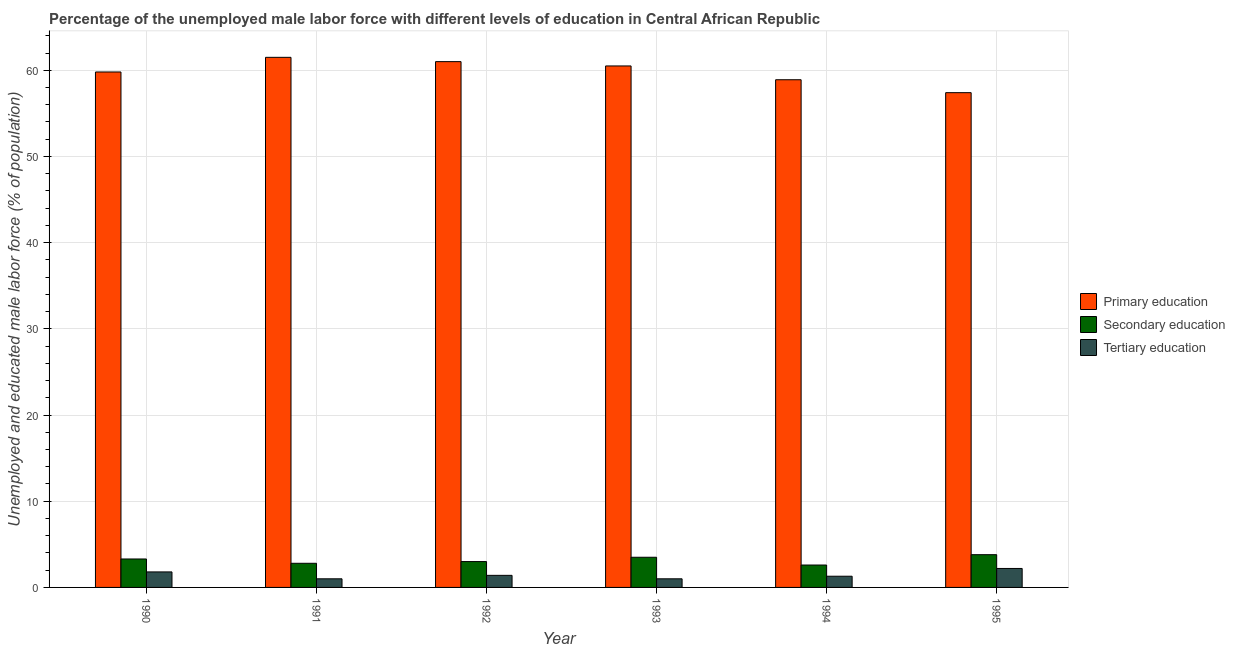How many groups of bars are there?
Provide a short and direct response. 6. How many bars are there on the 4th tick from the right?
Your answer should be very brief. 3. In how many cases, is the number of bars for a given year not equal to the number of legend labels?
Provide a short and direct response. 0. What is the percentage of male labor force who received primary education in 1993?
Make the answer very short. 60.5. Across all years, what is the maximum percentage of male labor force who received secondary education?
Your response must be concise. 3.8. Across all years, what is the minimum percentage of male labor force who received secondary education?
Offer a terse response. 2.6. In which year was the percentage of male labor force who received tertiary education maximum?
Keep it short and to the point. 1995. What is the total percentage of male labor force who received tertiary education in the graph?
Provide a short and direct response. 8.7. What is the difference between the percentage of male labor force who received primary education in 1991 and that in 1994?
Your response must be concise. 2.6. What is the difference between the percentage of male labor force who received primary education in 1991 and the percentage of male labor force who received secondary education in 1992?
Offer a terse response. 0.5. What is the average percentage of male labor force who received primary education per year?
Your response must be concise. 59.85. In the year 1991, what is the difference between the percentage of male labor force who received tertiary education and percentage of male labor force who received primary education?
Keep it short and to the point. 0. What is the ratio of the percentage of male labor force who received primary education in 1992 to that in 1993?
Make the answer very short. 1.01. Is the difference between the percentage of male labor force who received primary education in 1991 and 1993 greater than the difference between the percentage of male labor force who received secondary education in 1991 and 1993?
Make the answer very short. No. What is the difference between the highest and the second highest percentage of male labor force who received primary education?
Your response must be concise. 0.5. What is the difference between the highest and the lowest percentage of male labor force who received primary education?
Provide a succinct answer. 4.1. What does the 1st bar from the right in 1994 represents?
Provide a succinct answer. Tertiary education. Is it the case that in every year, the sum of the percentage of male labor force who received primary education and percentage of male labor force who received secondary education is greater than the percentage of male labor force who received tertiary education?
Your answer should be very brief. Yes. How many bars are there?
Give a very brief answer. 18. What is the difference between two consecutive major ticks on the Y-axis?
Make the answer very short. 10. Does the graph contain any zero values?
Your answer should be compact. No. How many legend labels are there?
Your answer should be compact. 3. How are the legend labels stacked?
Provide a short and direct response. Vertical. What is the title of the graph?
Your answer should be very brief. Percentage of the unemployed male labor force with different levels of education in Central African Republic. Does "Social insurance" appear as one of the legend labels in the graph?
Offer a very short reply. No. What is the label or title of the X-axis?
Give a very brief answer. Year. What is the label or title of the Y-axis?
Provide a succinct answer. Unemployed and educated male labor force (% of population). What is the Unemployed and educated male labor force (% of population) in Primary education in 1990?
Provide a succinct answer. 59.8. What is the Unemployed and educated male labor force (% of population) in Secondary education in 1990?
Your response must be concise. 3.3. What is the Unemployed and educated male labor force (% of population) in Tertiary education in 1990?
Keep it short and to the point. 1.8. What is the Unemployed and educated male labor force (% of population) of Primary education in 1991?
Ensure brevity in your answer.  61.5. What is the Unemployed and educated male labor force (% of population) of Secondary education in 1991?
Ensure brevity in your answer.  2.8. What is the Unemployed and educated male labor force (% of population) in Tertiary education in 1992?
Your response must be concise. 1.4. What is the Unemployed and educated male labor force (% of population) in Primary education in 1993?
Provide a succinct answer. 60.5. What is the Unemployed and educated male labor force (% of population) of Tertiary education in 1993?
Your response must be concise. 1. What is the Unemployed and educated male labor force (% of population) in Primary education in 1994?
Ensure brevity in your answer.  58.9. What is the Unemployed and educated male labor force (% of population) in Secondary education in 1994?
Your response must be concise. 2.6. What is the Unemployed and educated male labor force (% of population) in Tertiary education in 1994?
Give a very brief answer. 1.3. What is the Unemployed and educated male labor force (% of population) in Primary education in 1995?
Give a very brief answer. 57.4. What is the Unemployed and educated male labor force (% of population) in Secondary education in 1995?
Offer a terse response. 3.8. What is the Unemployed and educated male labor force (% of population) in Tertiary education in 1995?
Offer a terse response. 2.2. Across all years, what is the maximum Unemployed and educated male labor force (% of population) of Primary education?
Make the answer very short. 61.5. Across all years, what is the maximum Unemployed and educated male labor force (% of population) of Secondary education?
Offer a terse response. 3.8. Across all years, what is the maximum Unemployed and educated male labor force (% of population) in Tertiary education?
Provide a short and direct response. 2.2. Across all years, what is the minimum Unemployed and educated male labor force (% of population) of Primary education?
Ensure brevity in your answer.  57.4. Across all years, what is the minimum Unemployed and educated male labor force (% of population) of Secondary education?
Your answer should be compact. 2.6. Across all years, what is the minimum Unemployed and educated male labor force (% of population) in Tertiary education?
Give a very brief answer. 1. What is the total Unemployed and educated male labor force (% of population) in Primary education in the graph?
Ensure brevity in your answer.  359.1. What is the total Unemployed and educated male labor force (% of population) of Secondary education in the graph?
Make the answer very short. 19. What is the difference between the Unemployed and educated male labor force (% of population) in Primary education in 1990 and that in 1991?
Give a very brief answer. -1.7. What is the difference between the Unemployed and educated male labor force (% of population) in Secondary education in 1990 and that in 1991?
Your answer should be very brief. 0.5. What is the difference between the Unemployed and educated male labor force (% of population) in Primary education in 1990 and that in 1992?
Keep it short and to the point. -1.2. What is the difference between the Unemployed and educated male labor force (% of population) in Secondary education in 1990 and that in 1992?
Make the answer very short. 0.3. What is the difference between the Unemployed and educated male labor force (% of population) of Tertiary education in 1990 and that in 1992?
Give a very brief answer. 0.4. What is the difference between the Unemployed and educated male labor force (% of population) in Primary education in 1990 and that in 1994?
Your answer should be compact. 0.9. What is the difference between the Unemployed and educated male labor force (% of population) of Tertiary education in 1990 and that in 1994?
Give a very brief answer. 0.5. What is the difference between the Unemployed and educated male labor force (% of population) in Secondary education in 1991 and that in 1993?
Your answer should be compact. -0.7. What is the difference between the Unemployed and educated male labor force (% of population) of Primary education in 1991 and that in 1994?
Provide a short and direct response. 2.6. What is the difference between the Unemployed and educated male labor force (% of population) of Tertiary education in 1991 and that in 1994?
Provide a succinct answer. -0.3. What is the difference between the Unemployed and educated male labor force (% of population) in Primary education in 1991 and that in 1995?
Your response must be concise. 4.1. What is the difference between the Unemployed and educated male labor force (% of population) in Tertiary education in 1991 and that in 1995?
Provide a succinct answer. -1.2. What is the difference between the Unemployed and educated male labor force (% of population) of Primary education in 1992 and that in 1993?
Provide a succinct answer. 0.5. What is the difference between the Unemployed and educated male labor force (% of population) in Secondary education in 1992 and that in 1994?
Ensure brevity in your answer.  0.4. What is the difference between the Unemployed and educated male labor force (% of population) of Secondary education in 1992 and that in 1995?
Offer a very short reply. -0.8. What is the difference between the Unemployed and educated male labor force (% of population) in Tertiary education in 1992 and that in 1995?
Your answer should be compact. -0.8. What is the difference between the Unemployed and educated male labor force (% of population) of Primary education in 1993 and that in 1994?
Your answer should be very brief. 1.6. What is the difference between the Unemployed and educated male labor force (% of population) of Secondary education in 1993 and that in 1994?
Offer a terse response. 0.9. What is the difference between the Unemployed and educated male labor force (% of population) in Tertiary education in 1993 and that in 1994?
Give a very brief answer. -0.3. What is the difference between the Unemployed and educated male labor force (% of population) in Primary education in 1993 and that in 1995?
Provide a succinct answer. 3.1. What is the difference between the Unemployed and educated male labor force (% of population) of Secondary education in 1993 and that in 1995?
Your answer should be very brief. -0.3. What is the difference between the Unemployed and educated male labor force (% of population) of Tertiary education in 1993 and that in 1995?
Offer a very short reply. -1.2. What is the difference between the Unemployed and educated male labor force (% of population) of Tertiary education in 1994 and that in 1995?
Your answer should be very brief. -0.9. What is the difference between the Unemployed and educated male labor force (% of population) of Primary education in 1990 and the Unemployed and educated male labor force (% of population) of Tertiary education in 1991?
Ensure brevity in your answer.  58.8. What is the difference between the Unemployed and educated male labor force (% of population) of Secondary education in 1990 and the Unemployed and educated male labor force (% of population) of Tertiary education in 1991?
Ensure brevity in your answer.  2.3. What is the difference between the Unemployed and educated male labor force (% of population) in Primary education in 1990 and the Unemployed and educated male labor force (% of population) in Secondary education in 1992?
Provide a succinct answer. 56.8. What is the difference between the Unemployed and educated male labor force (% of population) of Primary education in 1990 and the Unemployed and educated male labor force (% of population) of Tertiary education in 1992?
Keep it short and to the point. 58.4. What is the difference between the Unemployed and educated male labor force (% of population) of Primary education in 1990 and the Unemployed and educated male labor force (% of population) of Secondary education in 1993?
Provide a succinct answer. 56.3. What is the difference between the Unemployed and educated male labor force (% of population) in Primary education in 1990 and the Unemployed and educated male labor force (% of population) in Tertiary education in 1993?
Your response must be concise. 58.8. What is the difference between the Unemployed and educated male labor force (% of population) in Secondary education in 1990 and the Unemployed and educated male labor force (% of population) in Tertiary education in 1993?
Keep it short and to the point. 2.3. What is the difference between the Unemployed and educated male labor force (% of population) in Primary education in 1990 and the Unemployed and educated male labor force (% of population) in Secondary education in 1994?
Provide a short and direct response. 57.2. What is the difference between the Unemployed and educated male labor force (% of population) in Primary education in 1990 and the Unemployed and educated male labor force (% of population) in Tertiary education in 1994?
Your response must be concise. 58.5. What is the difference between the Unemployed and educated male labor force (% of population) of Secondary education in 1990 and the Unemployed and educated male labor force (% of population) of Tertiary education in 1994?
Your response must be concise. 2. What is the difference between the Unemployed and educated male labor force (% of population) of Primary education in 1990 and the Unemployed and educated male labor force (% of population) of Tertiary education in 1995?
Keep it short and to the point. 57.6. What is the difference between the Unemployed and educated male labor force (% of population) in Primary education in 1991 and the Unemployed and educated male labor force (% of population) in Secondary education in 1992?
Your answer should be very brief. 58.5. What is the difference between the Unemployed and educated male labor force (% of population) in Primary education in 1991 and the Unemployed and educated male labor force (% of population) in Tertiary education in 1992?
Offer a terse response. 60.1. What is the difference between the Unemployed and educated male labor force (% of population) in Secondary education in 1991 and the Unemployed and educated male labor force (% of population) in Tertiary education in 1992?
Keep it short and to the point. 1.4. What is the difference between the Unemployed and educated male labor force (% of population) in Primary education in 1991 and the Unemployed and educated male labor force (% of population) in Secondary education in 1993?
Provide a short and direct response. 58. What is the difference between the Unemployed and educated male labor force (% of population) in Primary education in 1991 and the Unemployed and educated male labor force (% of population) in Tertiary education in 1993?
Offer a terse response. 60.5. What is the difference between the Unemployed and educated male labor force (% of population) in Primary education in 1991 and the Unemployed and educated male labor force (% of population) in Secondary education in 1994?
Provide a succinct answer. 58.9. What is the difference between the Unemployed and educated male labor force (% of population) in Primary education in 1991 and the Unemployed and educated male labor force (% of population) in Tertiary education in 1994?
Keep it short and to the point. 60.2. What is the difference between the Unemployed and educated male labor force (% of population) in Primary education in 1991 and the Unemployed and educated male labor force (% of population) in Secondary education in 1995?
Your answer should be compact. 57.7. What is the difference between the Unemployed and educated male labor force (% of population) in Primary education in 1991 and the Unemployed and educated male labor force (% of population) in Tertiary education in 1995?
Provide a short and direct response. 59.3. What is the difference between the Unemployed and educated male labor force (% of population) in Primary education in 1992 and the Unemployed and educated male labor force (% of population) in Secondary education in 1993?
Offer a very short reply. 57.5. What is the difference between the Unemployed and educated male labor force (% of population) in Secondary education in 1992 and the Unemployed and educated male labor force (% of population) in Tertiary education in 1993?
Ensure brevity in your answer.  2. What is the difference between the Unemployed and educated male labor force (% of population) of Primary education in 1992 and the Unemployed and educated male labor force (% of population) of Secondary education in 1994?
Give a very brief answer. 58.4. What is the difference between the Unemployed and educated male labor force (% of population) in Primary education in 1992 and the Unemployed and educated male labor force (% of population) in Tertiary education in 1994?
Offer a terse response. 59.7. What is the difference between the Unemployed and educated male labor force (% of population) in Primary education in 1992 and the Unemployed and educated male labor force (% of population) in Secondary education in 1995?
Keep it short and to the point. 57.2. What is the difference between the Unemployed and educated male labor force (% of population) in Primary education in 1992 and the Unemployed and educated male labor force (% of population) in Tertiary education in 1995?
Keep it short and to the point. 58.8. What is the difference between the Unemployed and educated male labor force (% of population) in Secondary education in 1992 and the Unemployed and educated male labor force (% of population) in Tertiary education in 1995?
Offer a very short reply. 0.8. What is the difference between the Unemployed and educated male labor force (% of population) in Primary education in 1993 and the Unemployed and educated male labor force (% of population) in Secondary education in 1994?
Ensure brevity in your answer.  57.9. What is the difference between the Unemployed and educated male labor force (% of population) of Primary education in 1993 and the Unemployed and educated male labor force (% of population) of Tertiary education in 1994?
Give a very brief answer. 59.2. What is the difference between the Unemployed and educated male labor force (% of population) of Secondary education in 1993 and the Unemployed and educated male labor force (% of population) of Tertiary education in 1994?
Your answer should be very brief. 2.2. What is the difference between the Unemployed and educated male labor force (% of population) in Primary education in 1993 and the Unemployed and educated male labor force (% of population) in Secondary education in 1995?
Offer a very short reply. 56.7. What is the difference between the Unemployed and educated male labor force (% of population) of Primary education in 1993 and the Unemployed and educated male labor force (% of population) of Tertiary education in 1995?
Keep it short and to the point. 58.3. What is the difference between the Unemployed and educated male labor force (% of population) of Secondary education in 1993 and the Unemployed and educated male labor force (% of population) of Tertiary education in 1995?
Provide a short and direct response. 1.3. What is the difference between the Unemployed and educated male labor force (% of population) of Primary education in 1994 and the Unemployed and educated male labor force (% of population) of Secondary education in 1995?
Offer a very short reply. 55.1. What is the difference between the Unemployed and educated male labor force (% of population) of Primary education in 1994 and the Unemployed and educated male labor force (% of population) of Tertiary education in 1995?
Keep it short and to the point. 56.7. What is the difference between the Unemployed and educated male labor force (% of population) of Secondary education in 1994 and the Unemployed and educated male labor force (% of population) of Tertiary education in 1995?
Your answer should be very brief. 0.4. What is the average Unemployed and educated male labor force (% of population) in Primary education per year?
Give a very brief answer. 59.85. What is the average Unemployed and educated male labor force (% of population) of Secondary education per year?
Provide a succinct answer. 3.17. What is the average Unemployed and educated male labor force (% of population) of Tertiary education per year?
Offer a very short reply. 1.45. In the year 1990, what is the difference between the Unemployed and educated male labor force (% of population) of Primary education and Unemployed and educated male labor force (% of population) of Secondary education?
Offer a very short reply. 56.5. In the year 1990, what is the difference between the Unemployed and educated male labor force (% of population) of Primary education and Unemployed and educated male labor force (% of population) of Tertiary education?
Your response must be concise. 58. In the year 1990, what is the difference between the Unemployed and educated male labor force (% of population) in Secondary education and Unemployed and educated male labor force (% of population) in Tertiary education?
Offer a very short reply. 1.5. In the year 1991, what is the difference between the Unemployed and educated male labor force (% of population) of Primary education and Unemployed and educated male labor force (% of population) of Secondary education?
Offer a terse response. 58.7. In the year 1991, what is the difference between the Unemployed and educated male labor force (% of population) of Primary education and Unemployed and educated male labor force (% of population) of Tertiary education?
Your answer should be compact. 60.5. In the year 1992, what is the difference between the Unemployed and educated male labor force (% of population) in Primary education and Unemployed and educated male labor force (% of population) in Tertiary education?
Offer a terse response. 59.6. In the year 1992, what is the difference between the Unemployed and educated male labor force (% of population) in Secondary education and Unemployed and educated male labor force (% of population) in Tertiary education?
Give a very brief answer. 1.6. In the year 1993, what is the difference between the Unemployed and educated male labor force (% of population) in Primary education and Unemployed and educated male labor force (% of population) in Tertiary education?
Provide a succinct answer. 59.5. In the year 1993, what is the difference between the Unemployed and educated male labor force (% of population) of Secondary education and Unemployed and educated male labor force (% of population) of Tertiary education?
Your answer should be compact. 2.5. In the year 1994, what is the difference between the Unemployed and educated male labor force (% of population) of Primary education and Unemployed and educated male labor force (% of population) of Secondary education?
Offer a terse response. 56.3. In the year 1994, what is the difference between the Unemployed and educated male labor force (% of population) in Primary education and Unemployed and educated male labor force (% of population) in Tertiary education?
Provide a short and direct response. 57.6. In the year 1994, what is the difference between the Unemployed and educated male labor force (% of population) of Secondary education and Unemployed and educated male labor force (% of population) of Tertiary education?
Provide a short and direct response. 1.3. In the year 1995, what is the difference between the Unemployed and educated male labor force (% of population) of Primary education and Unemployed and educated male labor force (% of population) of Secondary education?
Make the answer very short. 53.6. In the year 1995, what is the difference between the Unemployed and educated male labor force (% of population) of Primary education and Unemployed and educated male labor force (% of population) of Tertiary education?
Your answer should be compact. 55.2. What is the ratio of the Unemployed and educated male labor force (% of population) of Primary education in 1990 to that in 1991?
Give a very brief answer. 0.97. What is the ratio of the Unemployed and educated male labor force (% of population) in Secondary education in 1990 to that in 1991?
Offer a terse response. 1.18. What is the ratio of the Unemployed and educated male labor force (% of population) in Primary education in 1990 to that in 1992?
Offer a terse response. 0.98. What is the ratio of the Unemployed and educated male labor force (% of population) in Primary education in 1990 to that in 1993?
Your answer should be compact. 0.99. What is the ratio of the Unemployed and educated male labor force (% of population) in Secondary education in 1990 to that in 1993?
Make the answer very short. 0.94. What is the ratio of the Unemployed and educated male labor force (% of population) in Tertiary education in 1990 to that in 1993?
Make the answer very short. 1.8. What is the ratio of the Unemployed and educated male labor force (% of population) in Primary education in 1990 to that in 1994?
Ensure brevity in your answer.  1.02. What is the ratio of the Unemployed and educated male labor force (% of population) in Secondary education in 1990 to that in 1994?
Make the answer very short. 1.27. What is the ratio of the Unemployed and educated male labor force (% of population) of Tertiary education in 1990 to that in 1994?
Provide a short and direct response. 1.38. What is the ratio of the Unemployed and educated male labor force (% of population) of Primary education in 1990 to that in 1995?
Keep it short and to the point. 1.04. What is the ratio of the Unemployed and educated male labor force (% of population) of Secondary education in 1990 to that in 1995?
Ensure brevity in your answer.  0.87. What is the ratio of the Unemployed and educated male labor force (% of population) in Tertiary education in 1990 to that in 1995?
Your answer should be very brief. 0.82. What is the ratio of the Unemployed and educated male labor force (% of population) in Primary education in 1991 to that in 1992?
Offer a terse response. 1.01. What is the ratio of the Unemployed and educated male labor force (% of population) in Secondary education in 1991 to that in 1992?
Offer a terse response. 0.93. What is the ratio of the Unemployed and educated male labor force (% of population) of Tertiary education in 1991 to that in 1992?
Provide a short and direct response. 0.71. What is the ratio of the Unemployed and educated male labor force (% of population) in Primary education in 1991 to that in 1993?
Offer a terse response. 1.02. What is the ratio of the Unemployed and educated male labor force (% of population) of Secondary education in 1991 to that in 1993?
Make the answer very short. 0.8. What is the ratio of the Unemployed and educated male labor force (% of population) of Tertiary education in 1991 to that in 1993?
Your answer should be very brief. 1. What is the ratio of the Unemployed and educated male labor force (% of population) in Primary education in 1991 to that in 1994?
Your answer should be very brief. 1.04. What is the ratio of the Unemployed and educated male labor force (% of population) in Secondary education in 1991 to that in 1994?
Give a very brief answer. 1.08. What is the ratio of the Unemployed and educated male labor force (% of population) in Tertiary education in 1991 to that in 1994?
Provide a short and direct response. 0.77. What is the ratio of the Unemployed and educated male labor force (% of population) in Primary education in 1991 to that in 1995?
Make the answer very short. 1.07. What is the ratio of the Unemployed and educated male labor force (% of population) in Secondary education in 1991 to that in 1995?
Provide a succinct answer. 0.74. What is the ratio of the Unemployed and educated male labor force (% of population) in Tertiary education in 1991 to that in 1995?
Your answer should be compact. 0.45. What is the ratio of the Unemployed and educated male labor force (% of population) of Primary education in 1992 to that in 1993?
Give a very brief answer. 1.01. What is the ratio of the Unemployed and educated male labor force (% of population) of Secondary education in 1992 to that in 1993?
Provide a succinct answer. 0.86. What is the ratio of the Unemployed and educated male labor force (% of population) of Primary education in 1992 to that in 1994?
Your answer should be very brief. 1.04. What is the ratio of the Unemployed and educated male labor force (% of population) of Secondary education in 1992 to that in 1994?
Provide a succinct answer. 1.15. What is the ratio of the Unemployed and educated male labor force (% of population) of Tertiary education in 1992 to that in 1994?
Your answer should be very brief. 1.08. What is the ratio of the Unemployed and educated male labor force (% of population) in Primary education in 1992 to that in 1995?
Offer a terse response. 1.06. What is the ratio of the Unemployed and educated male labor force (% of population) in Secondary education in 1992 to that in 1995?
Offer a terse response. 0.79. What is the ratio of the Unemployed and educated male labor force (% of population) of Tertiary education in 1992 to that in 1995?
Your answer should be compact. 0.64. What is the ratio of the Unemployed and educated male labor force (% of population) in Primary education in 1993 to that in 1994?
Ensure brevity in your answer.  1.03. What is the ratio of the Unemployed and educated male labor force (% of population) of Secondary education in 1993 to that in 1994?
Offer a terse response. 1.35. What is the ratio of the Unemployed and educated male labor force (% of population) of Tertiary education in 1993 to that in 1994?
Ensure brevity in your answer.  0.77. What is the ratio of the Unemployed and educated male labor force (% of population) of Primary education in 1993 to that in 1995?
Ensure brevity in your answer.  1.05. What is the ratio of the Unemployed and educated male labor force (% of population) in Secondary education in 1993 to that in 1995?
Keep it short and to the point. 0.92. What is the ratio of the Unemployed and educated male labor force (% of population) of Tertiary education in 1993 to that in 1995?
Provide a short and direct response. 0.45. What is the ratio of the Unemployed and educated male labor force (% of population) of Primary education in 1994 to that in 1995?
Keep it short and to the point. 1.03. What is the ratio of the Unemployed and educated male labor force (% of population) of Secondary education in 1994 to that in 1995?
Your answer should be very brief. 0.68. What is the ratio of the Unemployed and educated male labor force (% of population) of Tertiary education in 1994 to that in 1995?
Your answer should be compact. 0.59. What is the difference between the highest and the second highest Unemployed and educated male labor force (% of population) in Secondary education?
Offer a terse response. 0.3. What is the difference between the highest and the lowest Unemployed and educated male labor force (% of population) of Secondary education?
Make the answer very short. 1.2. What is the difference between the highest and the lowest Unemployed and educated male labor force (% of population) in Tertiary education?
Offer a very short reply. 1.2. 